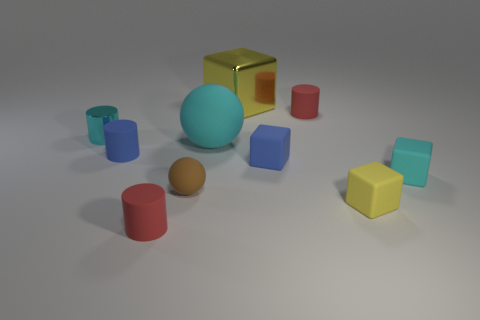Subtract all blue balls. Subtract all brown cylinders. How many balls are left? 2 Subtract all blocks. How many objects are left? 6 Add 4 large metallic cubes. How many large metallic cubes are left? 5 Add 7 large shiny cubes. How many large shiny cubes exist? 8 Subtract 0 brown blocks. How many objects are left? 10 Subtract all large yellow cubes. Subtract all small cyan cubes. How many objects are left? 8 